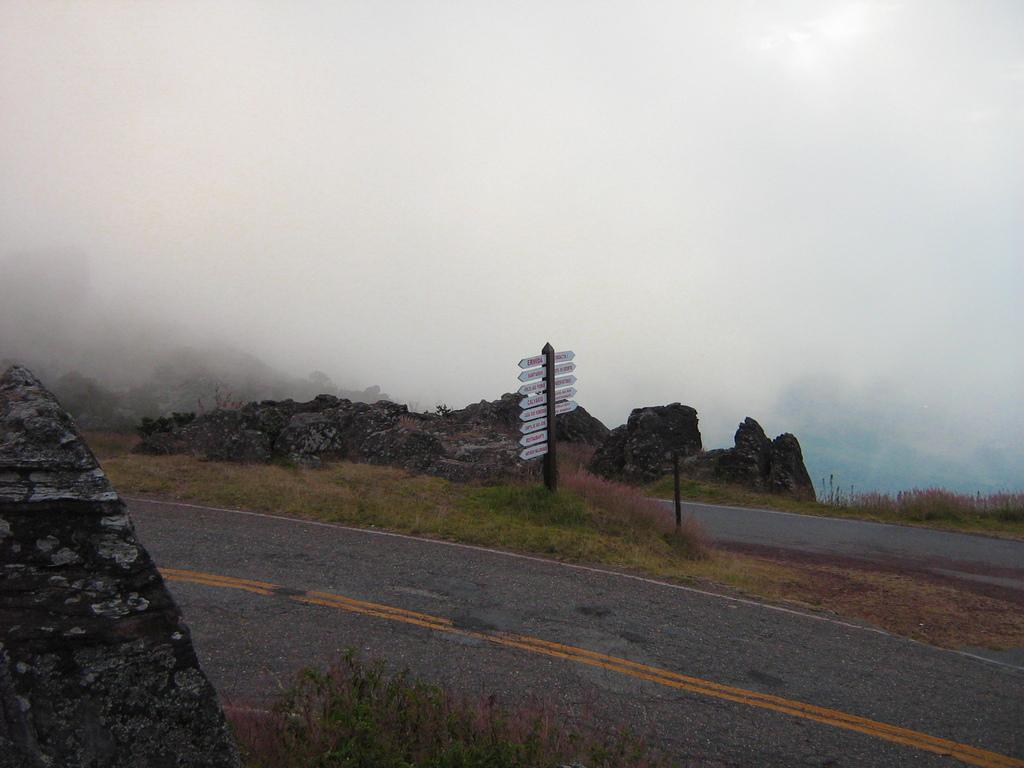What is the main feature of the image? There is a road in the image. What can be seen on either side of the road? Plants are present on either side of the road. What other objects or features can be seen in the image? Rocks are visible in the back of the image, and the sky is visible with clouds present. What type of pot is being used to cook rice in the image? There is no pot or rice present in the image; it features a road with plants, rocks, and a sky with clouds. 